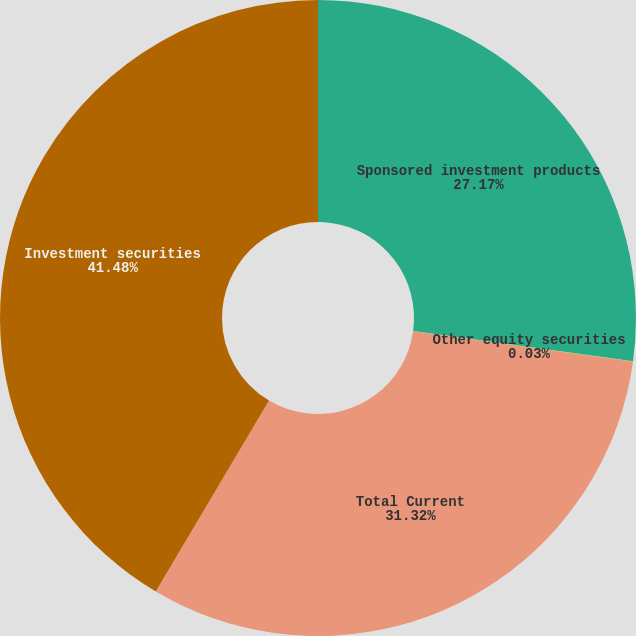Convert chart. <chart><loc_0><loc_0><loc_500><loc_500><pie_chart><fcel>Sponsored investment products<fcel>Other equity securities<fcel>Total Current<fcel>Investment securities<nl><fcel>27.17%<fcel>0.03%<fcel>31.32%<fcel>41.48%<nl></chart> 